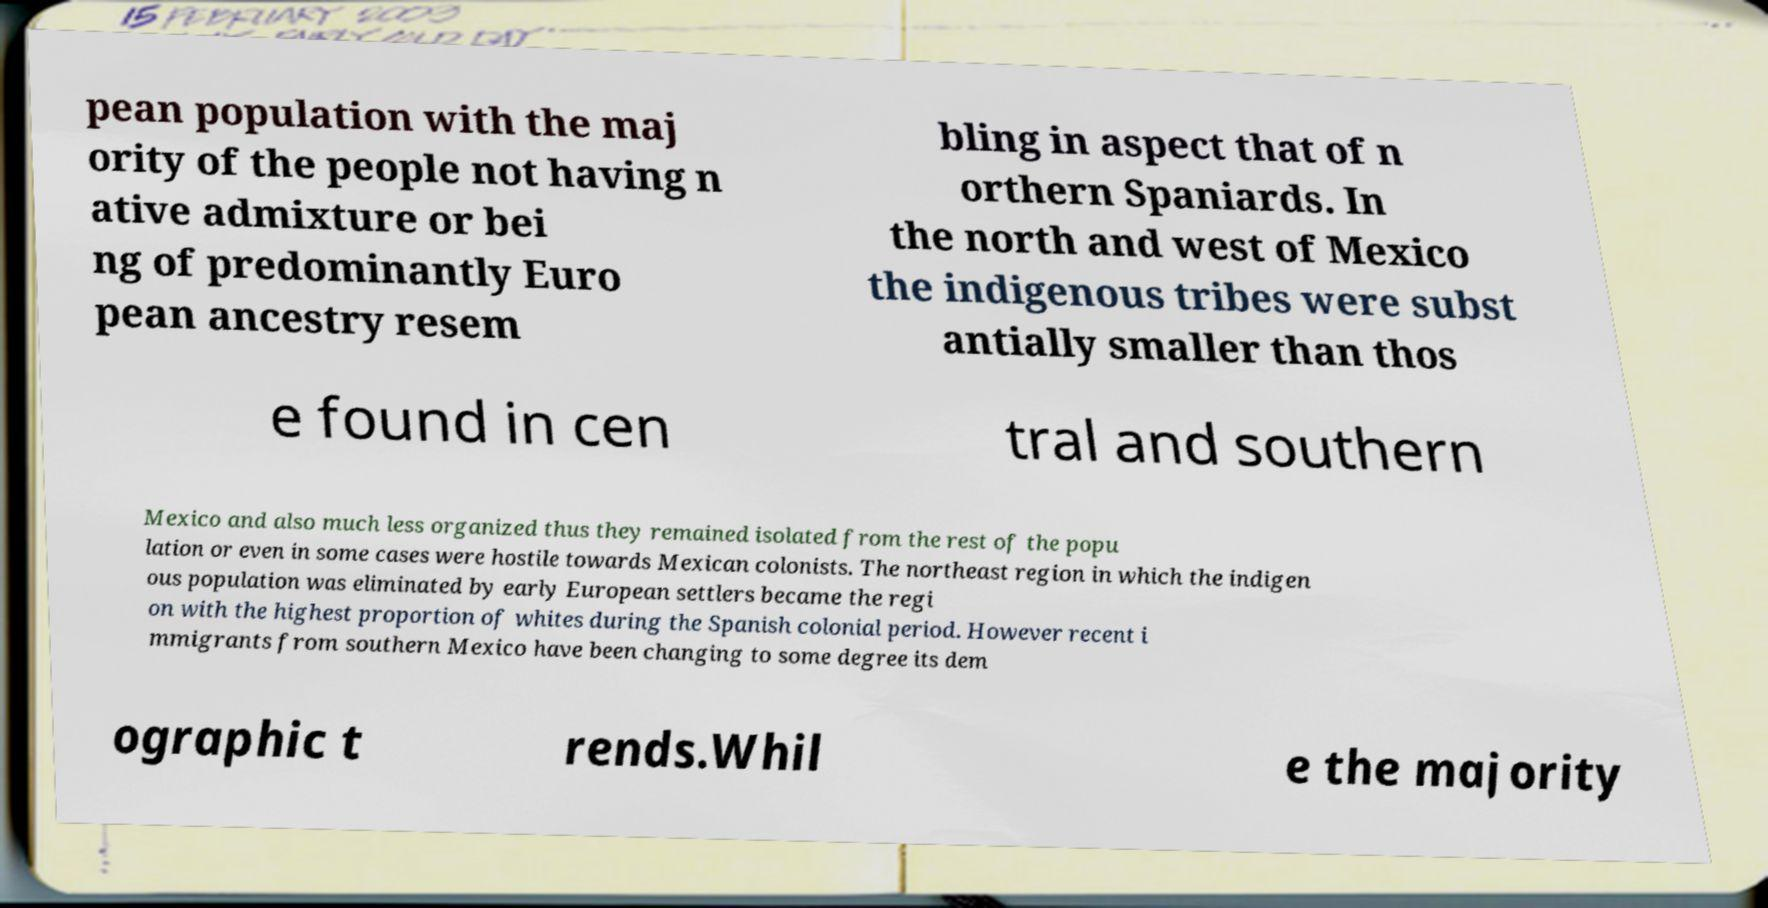I need the written content from this picture converted into text. Can you do that? pean population with the maj ority of the people not having n ative admixture or bei ng of predominantly Euro pean ancestry resem bling in aspect that of n orthern Spaniards. In the north and west of Mexico the indigenous tribes were subst antially smaller than thos e found in cen tral and southern Mexico and also much less organized thus they remained isolated from the rest of the popu lation or even in some cases were hostile towards Mexican colonists. The northeast region in which the indigen ous population was eliminated by early European settlers became the regi on with the highest proportion of whites during the Spanish colonial period. However recent i mmigrants from southern Mexico have been changing to some degree its dem ographic t rends.Whil e the majority 